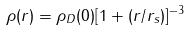<formula> <loc_0><loc_0><loc_500><loc_500>\rho ( r ) = \rho _ { D } ( 0 ) [ 1 + ( r / r _ { s } ) ] ^ { - 3 }</formula> 